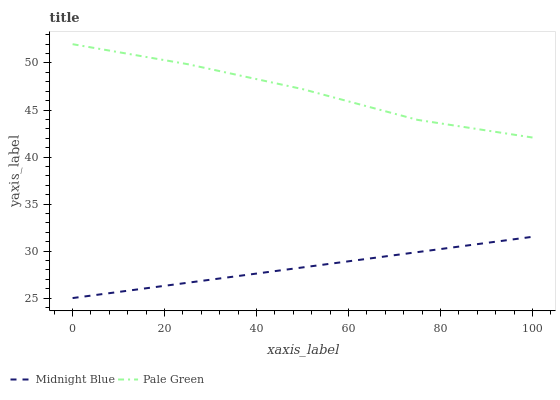Does Midnight Blue have the minimum area under the curve?
Answer yes or no. Yes. Does Pale Green have the maximum area under the curve?
Answer yes or no. Yes. Does Midnight Blue have the maximum area under the curve?
Answer yes or no. No. Is Midnight Blue the smoothest?
Answer yes or no. Yes. Is Pale Green the roughest?
Answer yes or no. Yes. Is Midnight Blue the roughest?
Answer yes or no. No. Does Midnight Blue have the highest value?
Answer yes or no. No. Is Midnight Blue less than Pale Green?
Answer yes or no. Yes. Is Pale Green greater than Midnight Blue?
Answer yes or no. Yes. Does Midnight Blue intersect Pale Green?
Answer yes or no. No. 